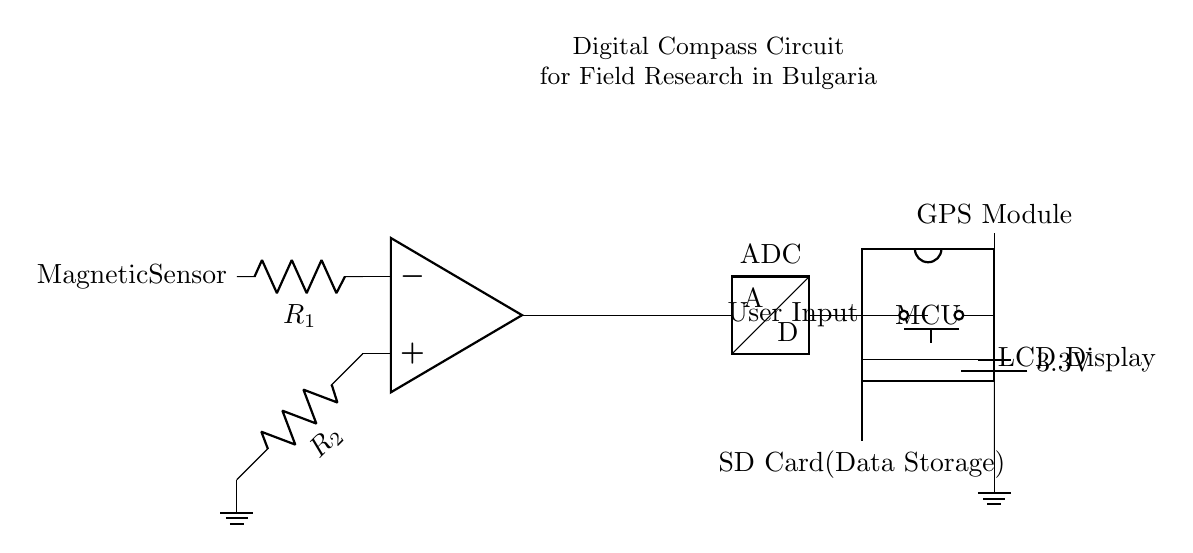What type of sensor is used in this circuit? The circuit diagram specifically labels a component as the Magnetic Sensor, which is responsible for detecting magnetic fields and providing input to the analog section of the circuit.
Answer: Magnetic Sensor What is the voltage supplied to the circuit? The circuit shows that there is a battery connected providing a voltage of 3.3V, indicated next to the power supply symbol in the diagram.
Answer: 3.3V Which component stores data in this circuit? The SD Card is clearly labeled in the circuit diagram as responsible for data storage, connected to the microcontroller unit (MCU) for saving data related to navigation and field research.
Answer: SD Card How many pins does the microcontroller have? The microcontroller symbol indicates that it has six pins, as represented in the circuit by the dipchip icon with external pins connected.
Answer: Six What is the purpose of the GPS module in the circuit? The GPS Module in the circuit is connected to the MCU and its role is to provide geographical positioning data, which is important for navigation, especially in field research settings.
Answer: Geographical positioning Which component provides user input? The circuit diagram includes a push button labeled User Input, directly connected to the microcontroller, allowing for input from the user to interact with the digital compass.
Answer: Push Button How does the output from the analog section connect to the ADC? The output of the operational amplifier (op amp) is shown to connect directly to the ADC, with a short wire between them labeled as adc_in, indicating that this output serves as the input for the analog-to-digital conversion process.
Answer: Direct connection 